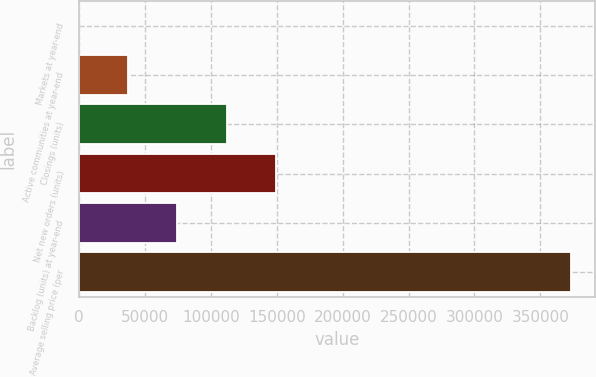<chart> <loc_0><loc_0><loc_500><loc_500><bar_chart><fcel>Markets at year-end<fcel>Active communities at year-end<fcel>Closings (units)<fcel>Net new orders (units)<fcel>Backlog (units) at year-end<fcel>Average selling price (per<nl><fcel>49<fcel>37344.1<fcel>111934<fcel>149229<fcel>74639.2<fcel>373000<nl></chart> 